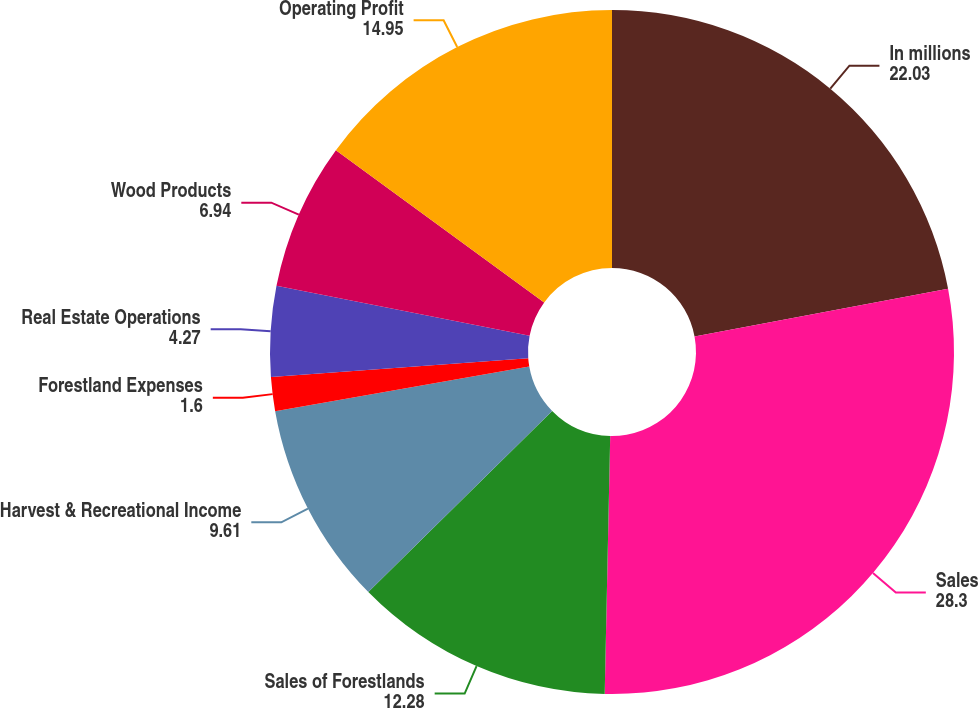<chart> <loc_0><loc_0><loc_500><loc_500><pie_chart><fcel>In millions<fcel>Sales<fcel>Sales of Forestlands<fcel>Harvest & Recreational Income<fcel>Forestland Expenses<fcel>Real Estate Operations<fcel>Wood Products<fcel>Operating Profit<nl><fcel>22.03%<fcel>28.3%<fcel>12.28%<fcel>9.61%<fcel>1.6%<fcel>4.27%<fcel>6.94%<fcel>14.95%<nl></chart> 